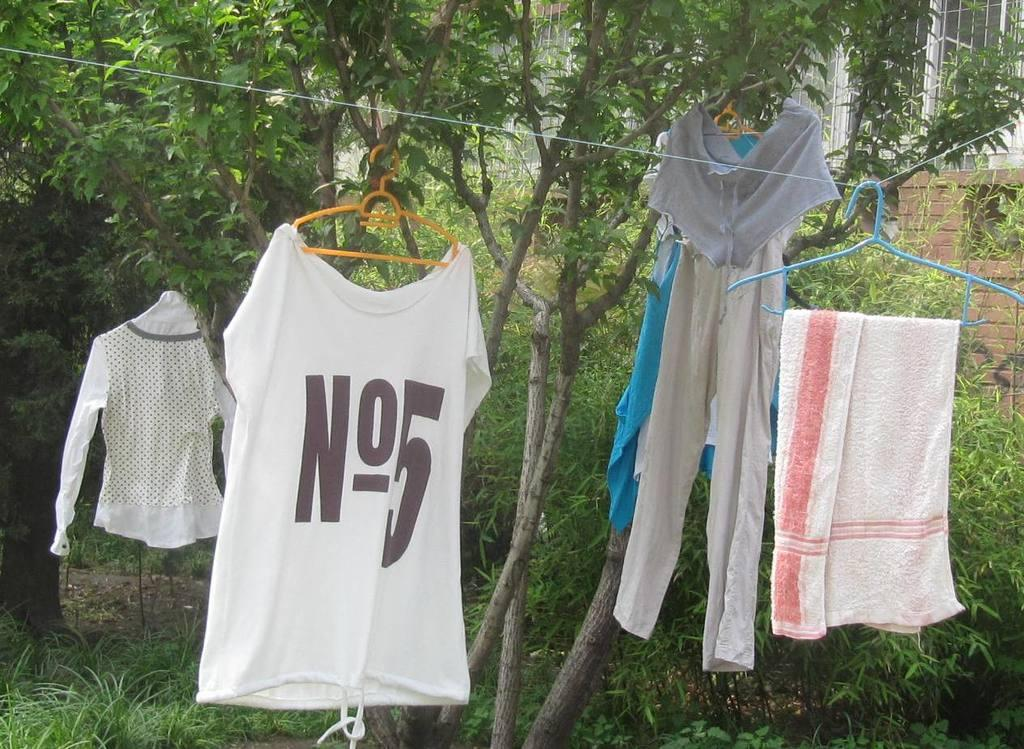<image>
Render a clear and concise summary of the photo. White, short sleeve number 5 jersey on yellow hanger on clothesline with four other clothing items. 